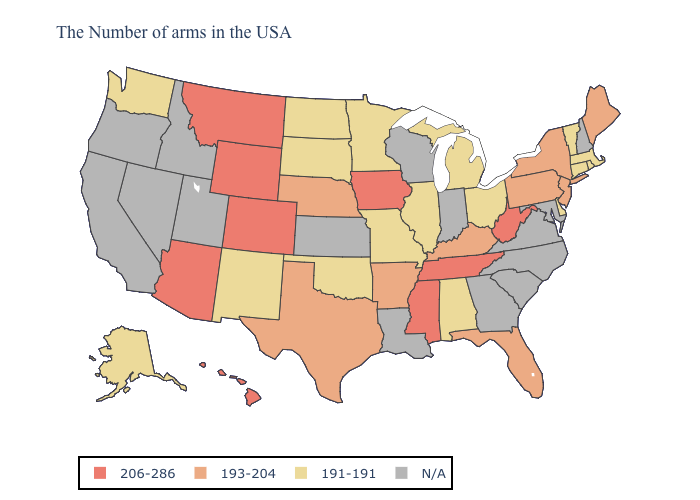Name the states that have a value in the range 193-204?
Keep it brief. Maine, New York, New Jersey, Pennsylvania, Florida, Kentucky, Arkansas, Nebraska, Texas. What is the value of Oklahoma?
Quick response, please. 191-191. Among the states that border New Mexico , which have the highest value?
Concise answer only. Colorado, Arizona. Does Ohio have the lowest value in the USA?
Concise answer only. Yes. Which states have the highest value in the USA?
Give a very brief answer. West Virginia, Tennessee, Mississippi, Iowa, Wyoming, Colorado, Montana, Arizona, Hawaii. What is the value of Minnesota?
Short answer required. 191-191. What is the highest value in the South ?
Keep it brief. 206-286. What is the value of Kansas?
Quick response, please. N/A. What is the value of Washington?
Give a very brief answer. 191-191. Name the states that have a value in the range 191-191?
Give a very brief answer. Massachusetts, Rhode Island, Vermont, Connecticut, Delaware, Ohio, Michigan, Alabama, Illinois, Missouri, Minnesota, Oklahoma, South Dakota, North Dakota, New Mexico, Washington, Alaska. Among the states that border Pennsylvania , which have the lowest value?
Be succinct. Delaware, Ohio. Does Hawaii have the highest value in the USA?
Short answer required. Yes. What is the value of Utah?
Keep it brief. N/A. Does South Dakota have the lowest value in the USA?
Concise answer only. Yes. 